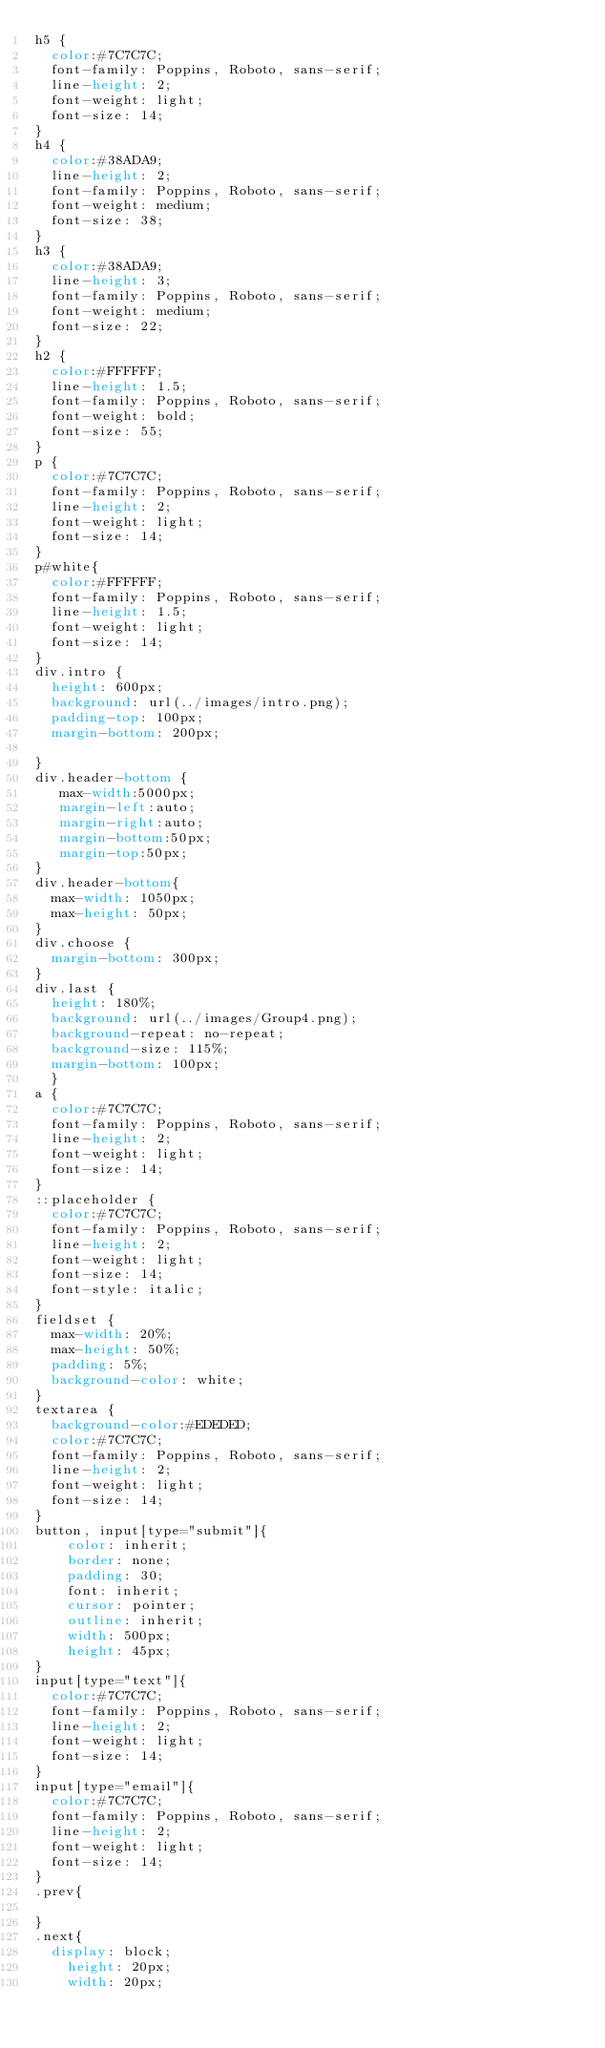Convert code to text. <code><loc_0><loc_0><loc_500><loc_500><_CSS_>h5 {
	color:#7C7C7C;
	font-family: Poppins, Roboto, sans-serif;
	line-height: 2;
	font-weight: light;
	font-size: 14;
}
h4 {
	color:#38ADA9;
	line-height: 2;
	font-family: Poppins, Roboto, sans-serif;
	font-weight: medium;
	font-size: 38;
}
h3 {
	color:#38ADA9;
	line-height: 3;
	font-family: Poppins, Roboto, sans-serif;
	font-weight: medium;
	font-size: 22;
}
h2 {
	color:#FFFFFF;
	line-height: 1.5;
	font-family: Poppins, Roboto, sans-serif;
	font-weight: bold;
	font-size: 55;
}
p {
	color:#7C7C7C;
	font-family: Poppins, Roboto, sans-serif;
	line-height: 2;
	font-weight: light;
	font-size: 14;
}
p#white{
	color:#FFFFFF;
	font-family: Poppins, Roboto, sans-serif;
	line-height: 1.5;
	font-weight: light;
	font-size: 14;
}
div.intro {
	height: 600px;
	background: url(../images/intro.png);
	padding-top: 100px;
	margin-bottom: 200px;

}
div.header-bottom {
	 max-width:5000px;
	 margin-left:auto;
	 margin-right:auto;
	 margin-bottom:50px;
	 margin-top:50px;
}
div.header-bottom{
	max-width: 1050px;
	max-height: 50px;
}
div.choose {
	margin-bottom: 300px;
}
div.last {
	height: 180%;
	background: url(../images/Group4.png);
	background-repeat: no-repeat;
	background-size: 115%;
	margin-bottom: 100px;
	}
a {
	color:#7C7C7C;
	font-family: Poppins, Roboto, sans-serif;
	line-height: 2;
	font-weight: light;
	font-size: 14;
}
::placeholder {
	color:#7C7C7C;
	font-family: Poppins, Roboto, sans-serif;
	line-height: 2;
	font-weight: light;
	font-size: 14;
	font-style: italic;
}
fieldset {
	max-width: 20%;
	max-height: 50%;
	padding: 5%;
	background-color: white; 
}
textarea {
	background-color:#EDEDED;
	color:#7C7C7C;
	font-family: Poppins, Roboto, sans-serif;
	line-height: 2;
	font-weight: light;
	font-size: 14;
}
button, input[type="submit"]{
    color: inherit;
    border: none;
    padding: 30;
    font: inherit;
    cursor: pointer;
    outline: inherit;
    width: 500px;
    height: 45px;
}
input[type="text"]{
	color:#7C7C7C;
	font-family: Poppins, Roboto, sans-serif;
	line-height: 2;
	font-weight: light;
	font-size: 14;
}
input[type="email"]{
	color:#7C7C7C;
	font-family: Poppins, Roboto, sans-serif;
	line-height: 2;
	font-weight: light;
	font-size: 14;
}
.prev{

}
.next{
	display: block;
    height: 20px;
    width: 20px;</code> 